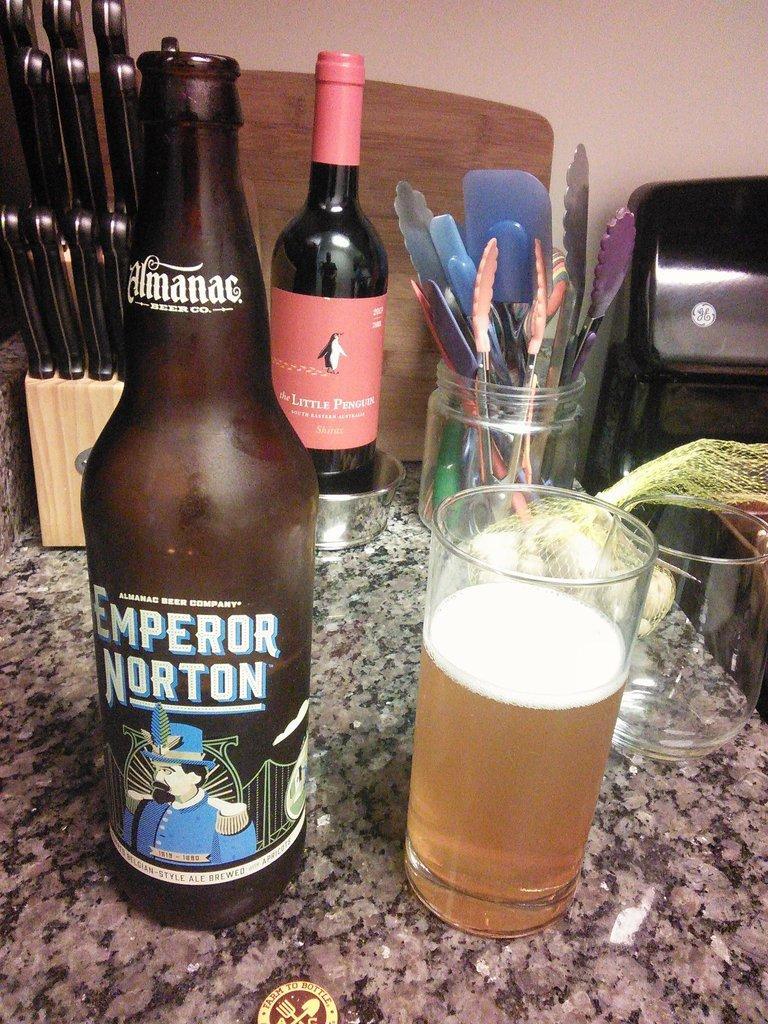Describe this image in one or two sentences. In this image there are two bottles a glass having drink in it and a knife stand at the left side of image and a jar having some kitchen tools in it on a marble stone. 